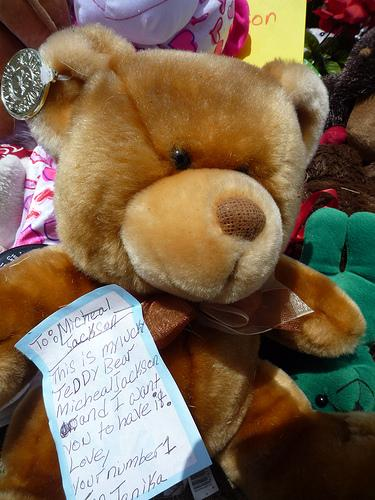What are the different colors visible in the image? Brown, black, gold, green, white, yellow, red, blue, and pink colors are visible in the image. Describe the overall appearance and theme of the image. The image features a brown teddy bear with various attached items and a background filled with other stuffed toys and flowers. Mention any accessories or details related to the main object in the image. The teddy bear has a brown woven nose, black eyes, a gold coin, and a ribbon tied around its neck. Provide a description of any additional objects or details in the image. A bar code tag is visible and there are red and pink hearts, a thin red ribbon, and a note stapled to the teddy bear. Provide a brief description of the primary object in the image. A brown stuffed teddy bear with a handwritten note attached to it. List any elements in the background of the image. A green upside-down teddy bear, stuffed toys, flowers, and a purple stuffed toy can be seen in the background. Identify any unique or special features of the main object in the image. The teddy bear has a shiny gold medallion attached to its ear and a handwritten note to Michael Jackson. What type of interaction or connection can be inferred from the main object in the image? The teddy bear with the attached note represents a fan's love and admiration for Michael Jackson. State the purpose or occasion for the main object in the image. The teddy bear is a gift to Michael Jackson from a fan named Tanika. Mention any text or writing visible in the image. A handwritten note addressed to Michael Jackson is attached to the teddy bear. 